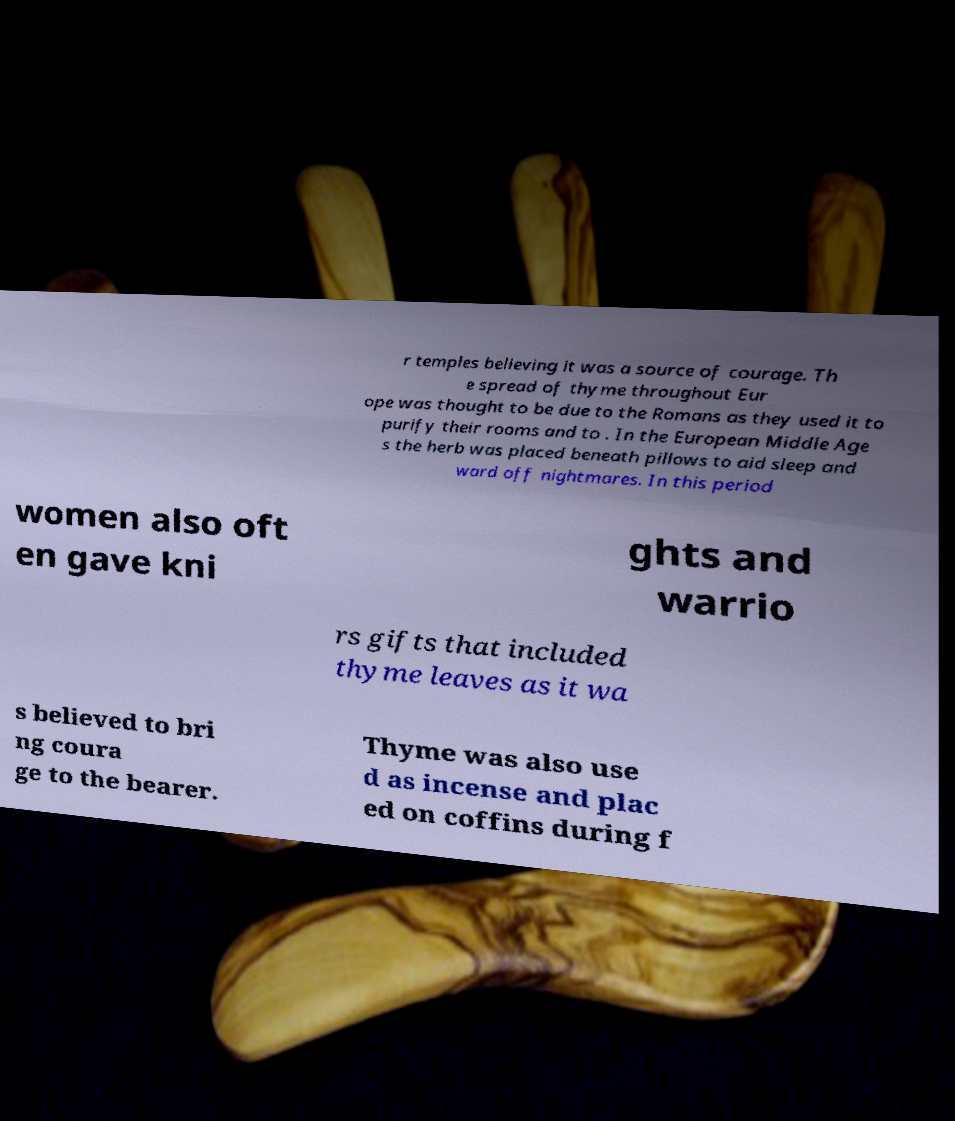Could you extract and type out the text from this image? r temples believing it was a source of courage. Th e spread of thyme throughout Eur ope was thought to be due to the Romans as they used it to purify their rooms and to . In the European Middle Age s the herb was placed beneath pillows to aid sleep and ward off nightmares. In this period women also oft en gave kni ghts and warrio rs gifts that included thyme leaves as it wa s believed to bri ng coura ge to the bearer. Thyme was also use d as incense and plac ed on coffins during f 